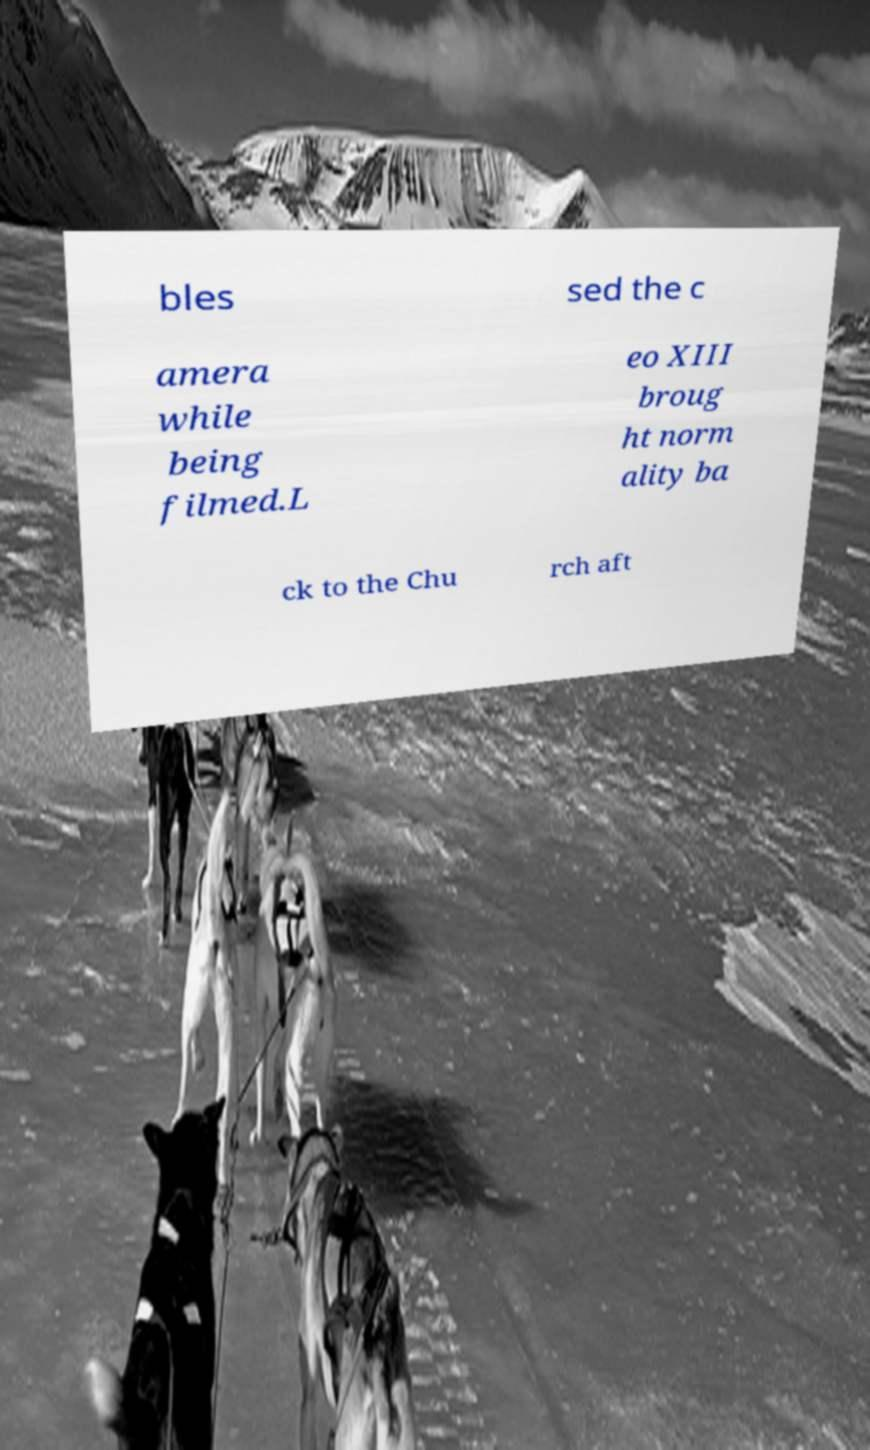Can you accurately transcribe the text from the provided image for me? bles sed the c amera while being filmed.L eo XIII broug ht norm ality ba ck to the Chu rch aft 